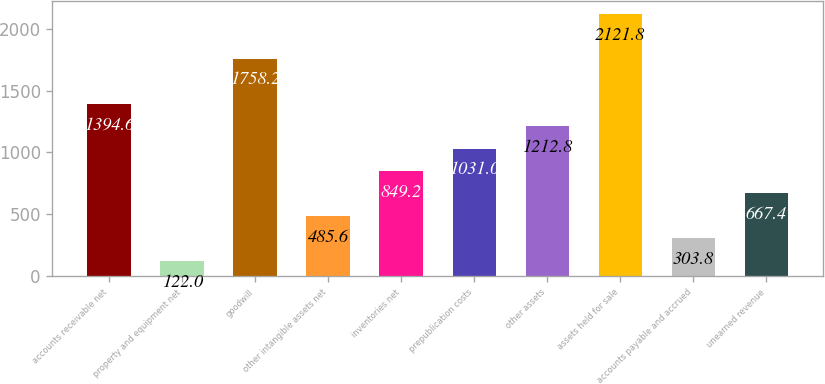Convert chart. <chart><loc_0><loc_0><loc_500><loc_500><bar_chart><fcel>accounts receivable net<fcel>property and equipment net<fcel>goodwill<fcel>other intangible assets net<fcel>inventories net<fcel>prepublication costs<fcel>other assets<fcel>assets held for sale<fcel>accounts payable and accrued<fcel>unearned revenue<nl><fcel>1394.6<fcel>122<fcel>1758.2<fcel>485.6<fcel>849.2<fcel>1031<fcel>1212.8<fcel>2121.8<fcel>303.8<fcel>667.4<nl></chart> 